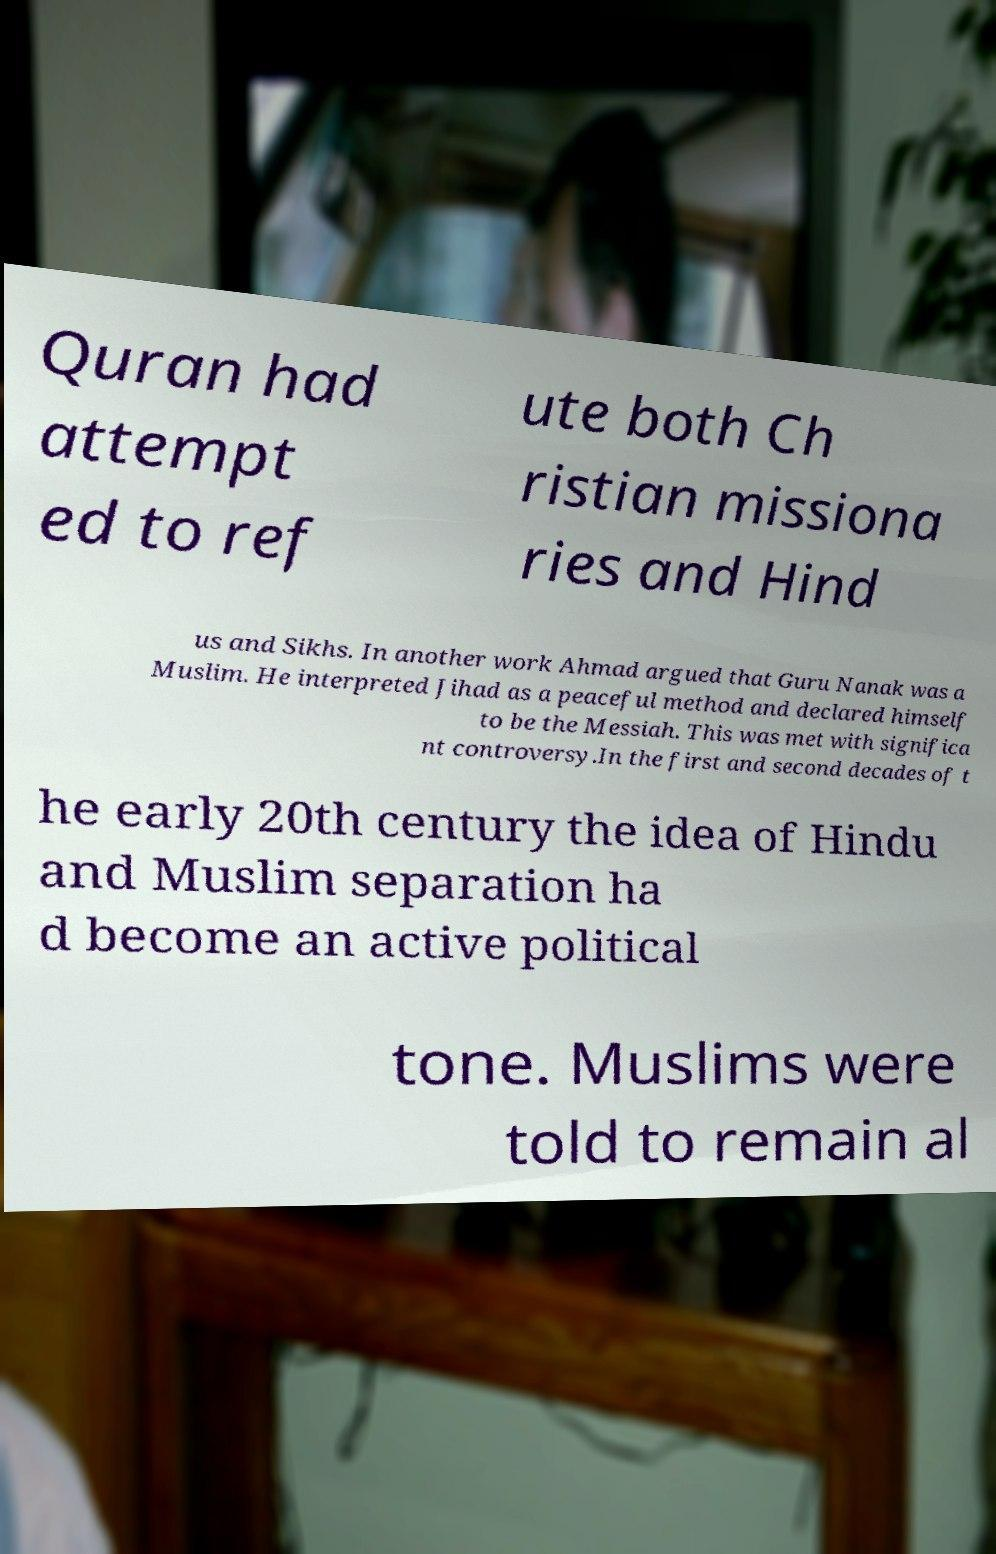For documentation purposes, I need the text within this image transcribed. Could you provide that? Quran had attempt ed to ref ute both Ch ristian missiona ries and Hind us and Sikhs. In another work Ahmad argued that Guru Nanak was a Muslim. He interpreted Jihad as a peaceful method and declared himself to be the Messiah. This was met with significa nt controversy.In the first and second decades of t he early 20th century the idea of Hindu and Muslim separation ha d become an active political tone. Muslims were told to remain al 